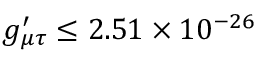<formula> <loc_0><loc_0><loc_500><loc_500>g _ { \mu \tau } ^ { \prime } \leq 2 . 5 1 \times 1 0 ^ { - 2 6 }</formula> 